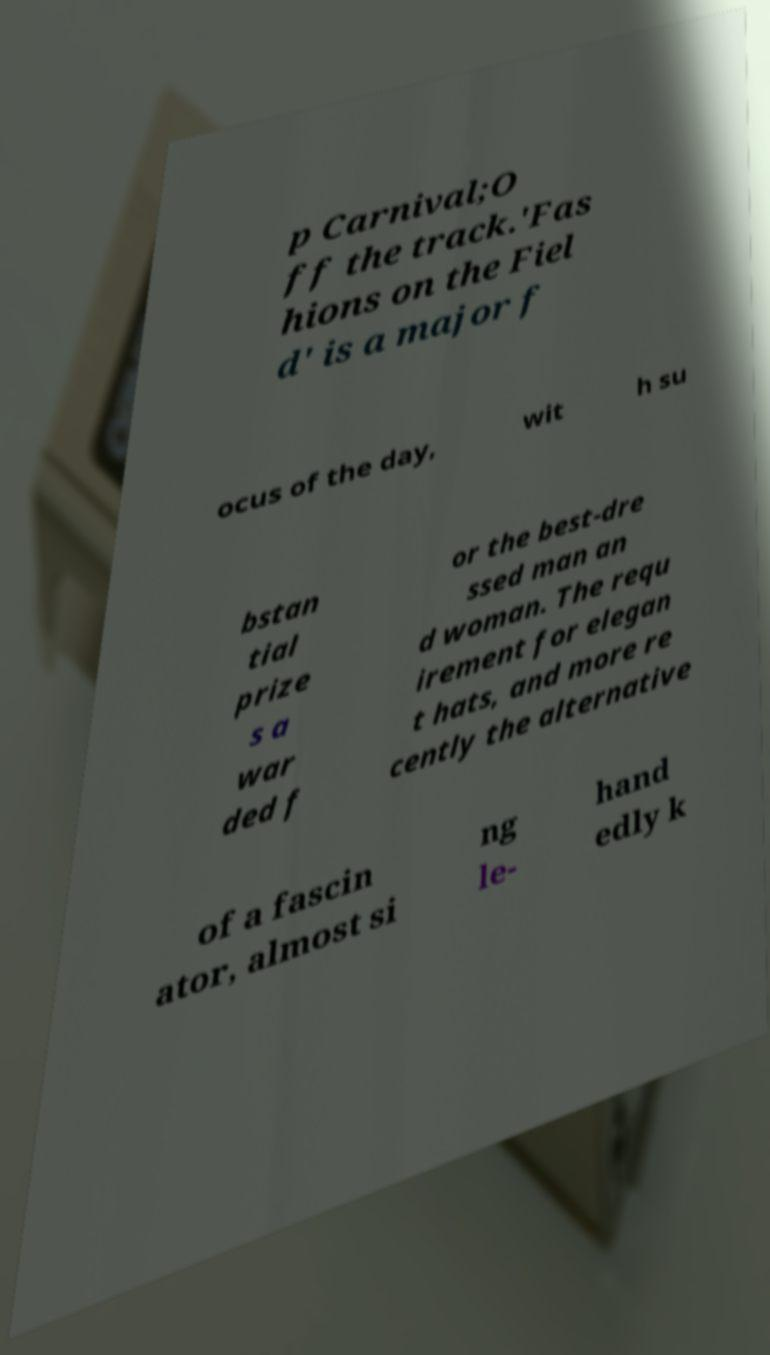Can you read and provide the text displayed in the image?This photo seems to have some interesting text. Can you extract and type it out for me? p Carnival;O ff the track.'Fas hions on the Fiel d' is a major f ocus of the day, wit h su bstan tial prize s a war ded f or the best-dre ssed man an d woman. The requ irement for elegan t hats, and more re cently the alternative of a fascin ator, almost si ng le- hand edly k 